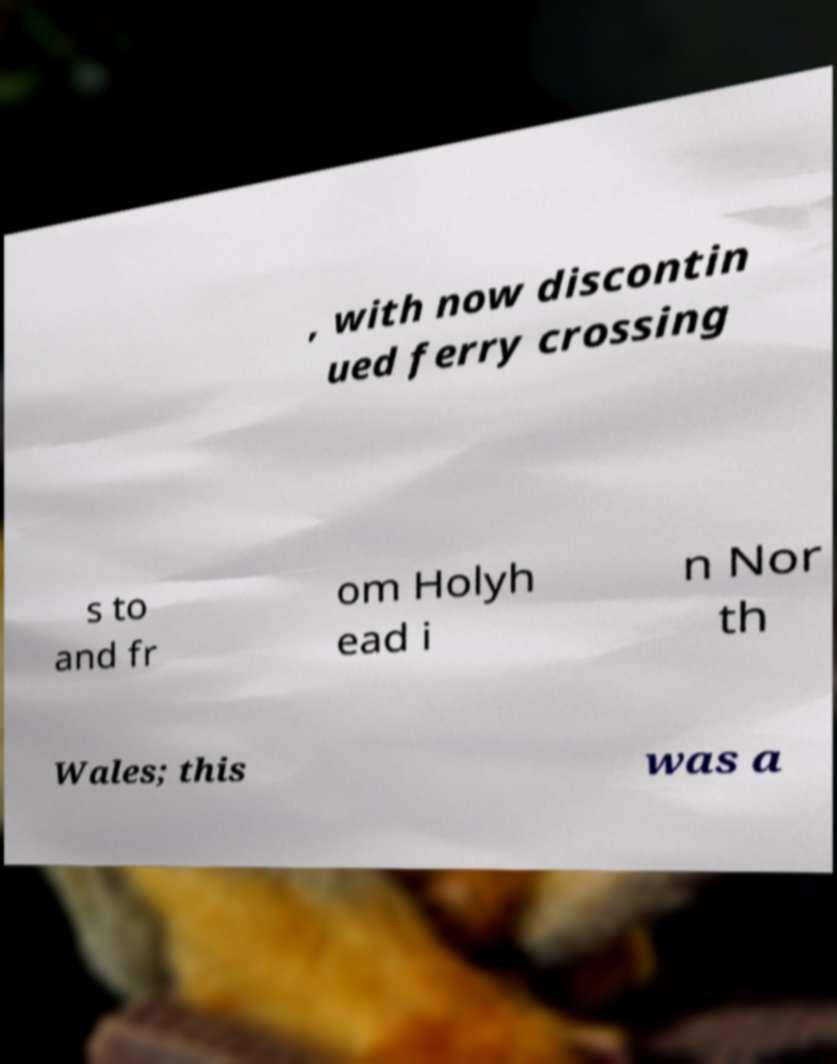There's text embedded in this image that I need extracted. Can you transcribe it verbatim? , with now discontin ued ferry crossing s to and fr om Holyh ead i n Nor th Wales; this was a 